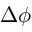Convert formula to latex. <formula><loc_0><loc_0><loc_500><loc_500>\Delta \phi</formula> 